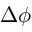Convert formula to latex. <formula><loc_0><loc_0><loc_500><loc_500>\Delta \phi</formula> 